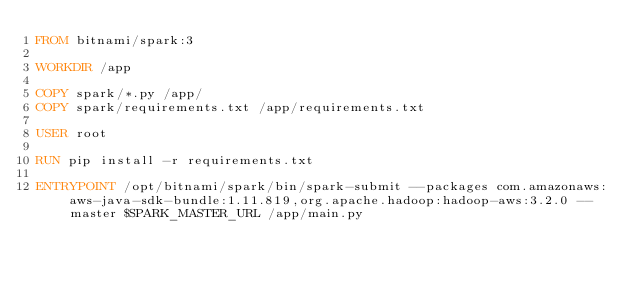<code> <loc_0><loc_0><loc_500><loc_500><_Dockerfile_>FROM bitnami/spark:3

WORKDIR /app

COPY spark/*.py /app/
COPY spark/requirements.txt /app/requirements.txt

USER root

RUN pip install -r requirements.txt

ENTRYPOINT /opt/bitnami/spark/bin/spark-submit --packages com.amazonaws:aws-java-sdk-bundle:1.11.819,org.apache.hadoop:hadoop-aws:3.2.0 --master $SPARK_MASTER_URL /app/main.py</code> 